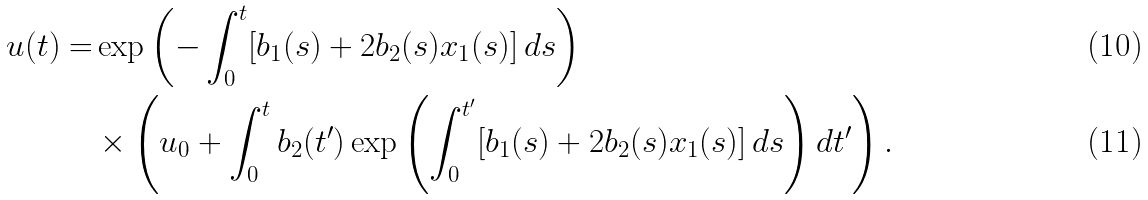Convert formula to latex. <formula><loc_0><loc_0><loc_500><loc_500>u ( t ) = & \exp \left ( - \int _ { 0 } ^ { t } [ b _ { 1 } ( s ) + 2 b _ { 2 } ( s ) x _ { 1 } ( s ) ] \, d s \right ) \\ & \times \left ( u _ { 0 } + \int _ { 0 } ^ { t } b _ { 2 } ( t ^ { \prime } ) \exp \left ( \int _ { 0 } ^ { t ^ { \prime } } [ b _ { 1 } ( s ) + 2 b _ { 2 } ( s ) x _ { 1 } ( s ) ] \, d s \right ) d t ^ { \prime } \right ) .</formula> 